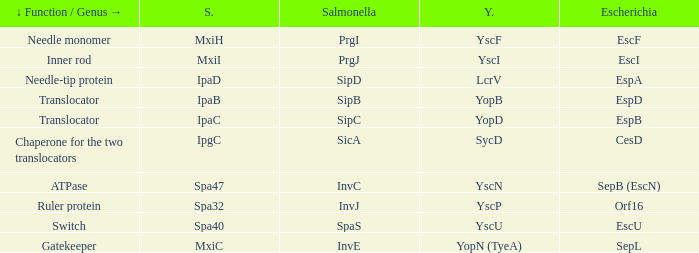Help me parse the entirety of this table. {'header': ['↓ Function / Genus →', 'S.', 'Salmonella', 'Y.', 'Escherichia'], 'rows': [['Needle monomer', 'MxiH', 'PrgI', 'YscF', 'EscF'], ['Inner rod', 'MxiI', 'PrgJ', 'YscI', 'EscI'], ['Needle-tip protein', 'IpaD', 'SipD', 'LcrV', 'EspA'], ['Translocator', 'IpaB', 'SipB', 'YopB', 'EspD'], ['Translocator', 'IpaC', 'SipC', 'YopD', 'EspB'], ['Chaperone for the two translocators', 'IpgC', 'SicA', 'SycD', 'CesD'], ['ATPase', 'Spa47', 'InvC', 'YscN', 'SepB (EscN)'], ['Ruler protein', 'Spa32', 'InvJ', 'YscP', 'Orf16'], ['Switch', 'Spa40', 'SpaS', 'YscU', 'EscU'], ['Gatekeeper', 'MxiC', 'InvE', 'YopN (TyeA)', 'SepL']]} Tell me the shigella for yersinia yopb IpaB. 